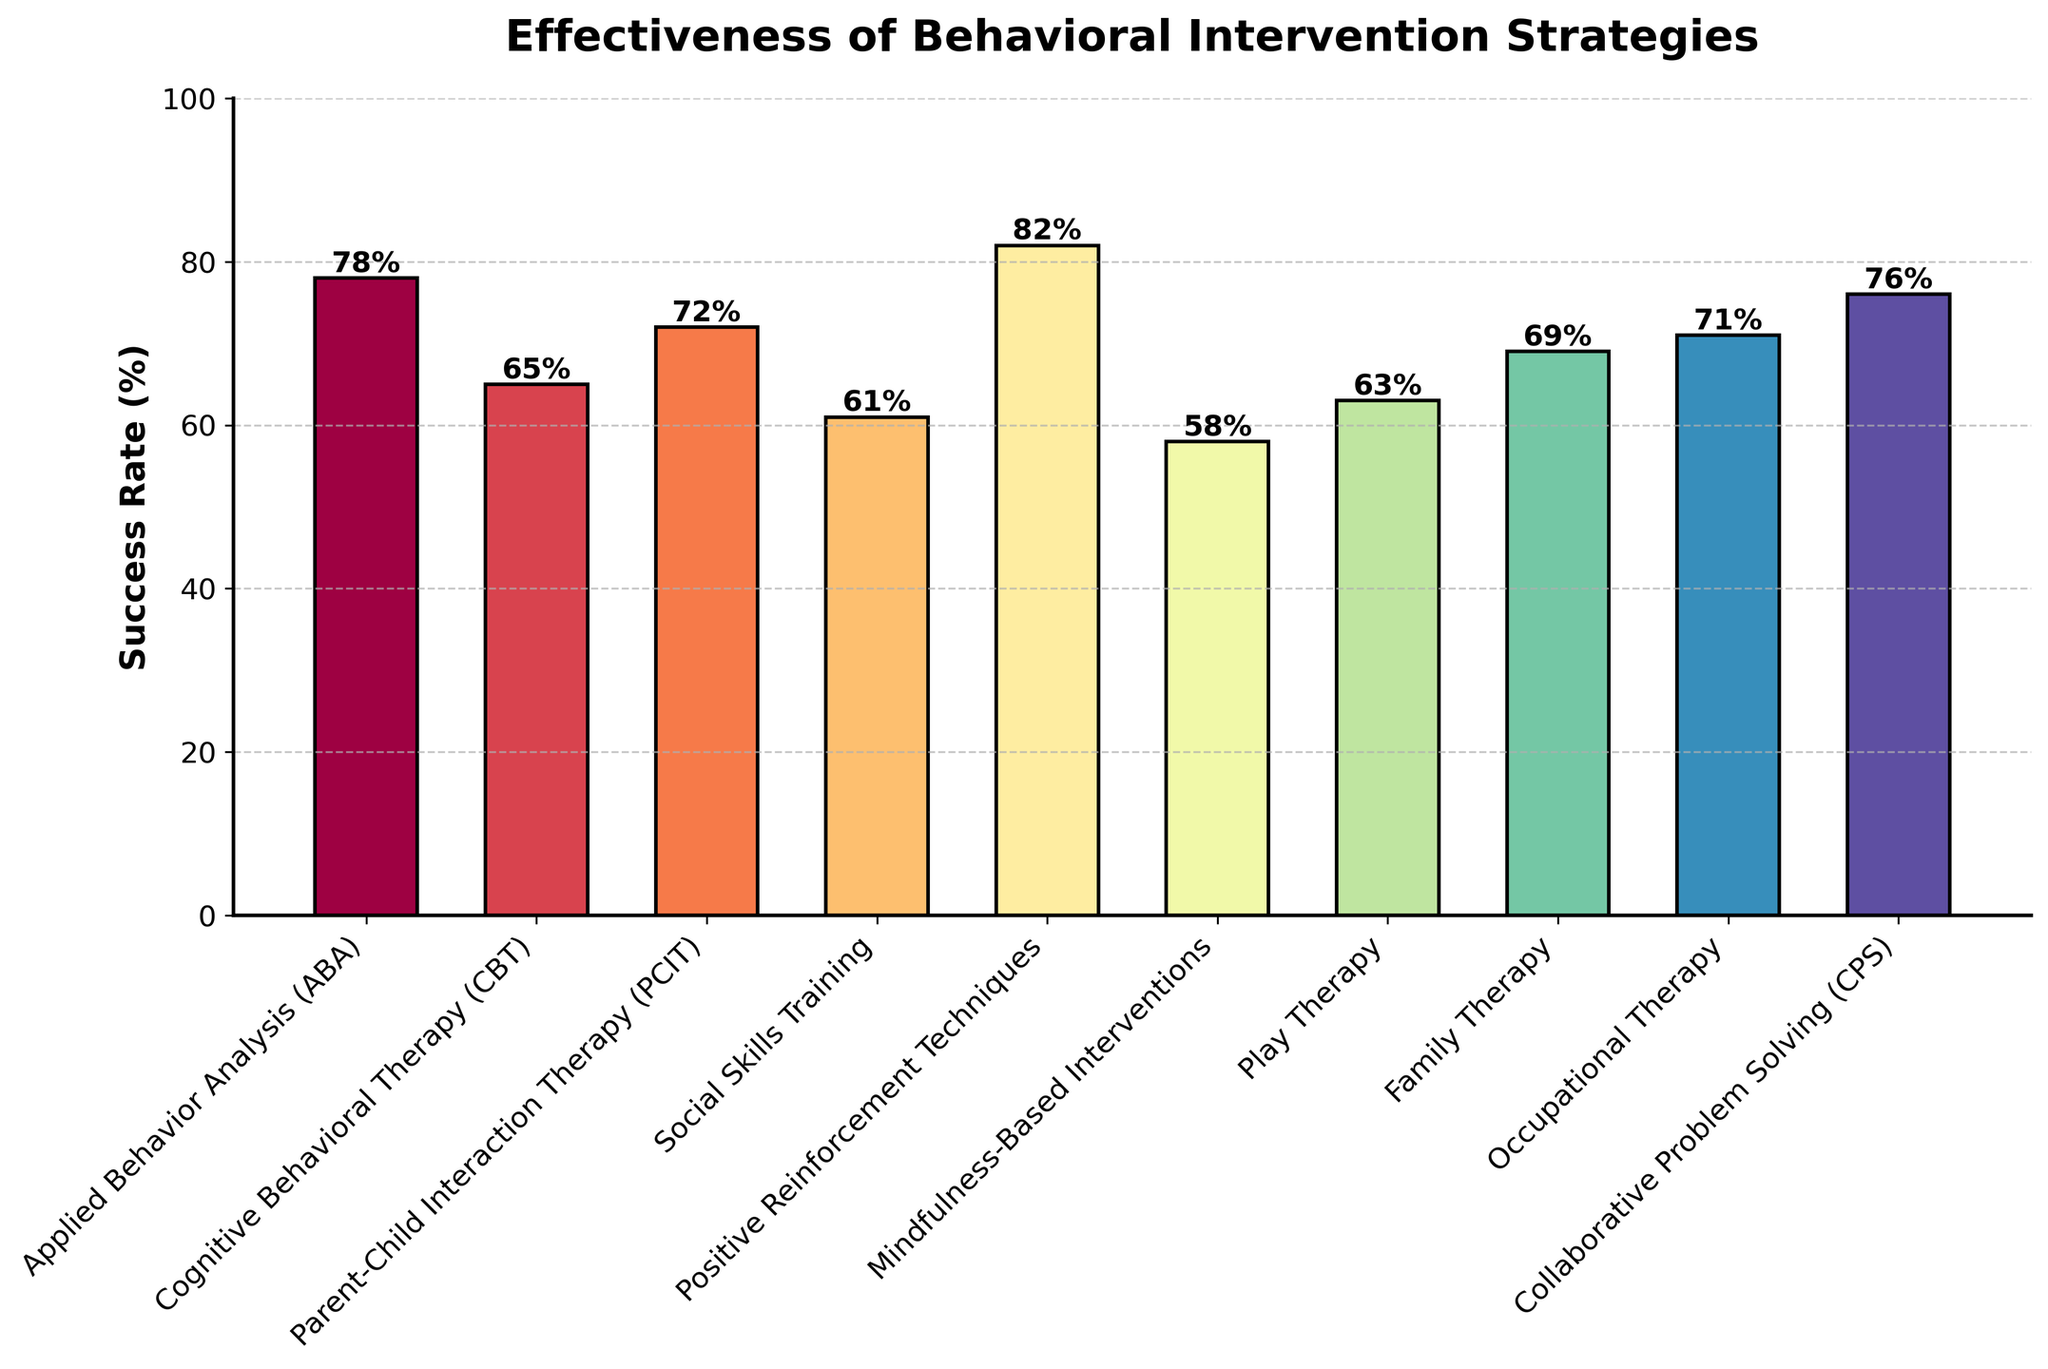What is the success rate of Positive Reinforcement Techniques? Look for the bar labeled "Positive Reinforcement Techniques" and read the value at the top of the bar, which indicates 82%.
Answer: 82% Which intervention strategy has the lowest success rate? Compare the heights of all the bars and identify the one with the smallest height, labeled "Mindfulness-Based Interventions," which shows 58%.
Answer: Mindfulness-Based Interventions How much higher is the success rate of Applied Behavior Analysis (ABA) compared to Play Therapy? Find the values for "Applied Behavior Analysis (ABA)" and "Play Therapy," which are 78% and 63%, respectively. Calculate the difference: 78% - 63% = 15%.
Answer: 15% Which strategies have success rates above 70%? Identify bars with heights exceeding the 70% line: "Applied Behavior Analysis (ABA)," "Parent-Child Interaction Therapy (PCIT)," "Positive Reinforcement Techniques," "Occupational Therapy," and "Collaborative Problem Solving (CPS)."
Answer: ABA, PCIT, Positive Reinforcement Techniques, Occupational Therapy, CPS What is the average success rate of all the strategies shown? Sum all the success rates and divide by the number of strategies: (78 + 65 + 72 + 61 + 82 + 58 + 63 + 69 + 71 + 76) / 10 = 69.5%.
Answer: 69.5% What is the difference in success rates between Cognitive Behavioral Therapy (CBT) and Social Skills Training? Find the values for "Cognitive Behavioral Therapy (CBT)" and "Social Skills Training," which are 65% and 61%, respectively. Calculate the difference: 65% - 61% = 4%.
Answer: 4% Does Parent-Child Interaction Therapy (PCIT) have a higher success rate than Family Therapy? Compare the heights of the bars for "Parent-Child Interaction Therapy (PCIT)" and "Family Therapy." PCIT shows 72% and Family Therapy shows 69%, so yes.
Answer: Yes What is the combined success rate of the highest and lowest performing strategies? Identify the highest (Positive Reinforcement Techniques at 82%) and lowest (Mindfulness-Based Interventions at 58%). Sum them up: 82% + 58% = 140%.
Answer: 140% Which intervention strategy is ranked second in terms of success rate? Order the bars from highest to lowest and find the second highest, which is "Applied Behavior Analysis (ABA)" at 78%.
Answer: Applied Behavior Analysis (ABA) What’s the median success rate of all the strategies presented? List the success rates in ascending order: 58, 61, 63, 65, 69, 71, 72, 76, 78, 82. As there are 10 values, the median is the average of the 5th and 6th values: (69 + 71) / 2 = 70%.
Answer: 70% 